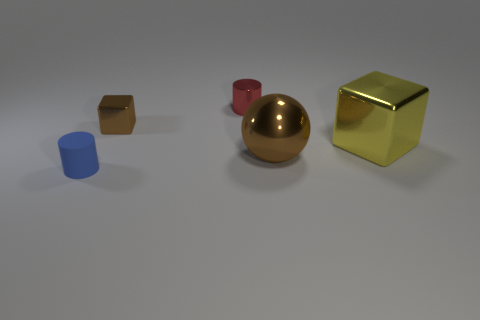Add 3 brown metal objects. How many objects exist? 8 Subtract 1 cylinders. How many cylinders are left? 1 Subtract all cylinders. How many objects are left? 3 Subtract all large green objects. Subtract all big yellow metallic cubes. How many objects are left? 4 Add 5 tiny brown blocks. How many tiny brown blocks are left? 6 Add 3 big gray metal things. How many big gray metal things exist? 3 Subtract 0 red blocks. How many objects are left? 5 Subtract all blue balls. Subtract all brown cubes. How many balls are left? 1 